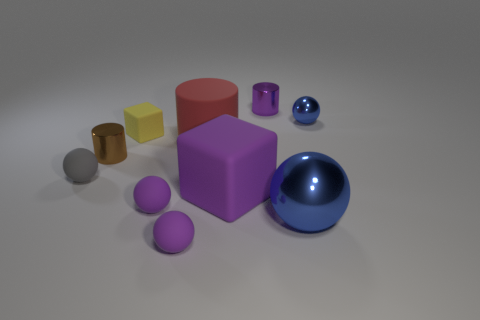There is a small shiny object that is the same shape as the big metallic thing; what color is it? The small shiny object that shares its spherical shape with the larger metallic sphere is blue, exhibiting a rich and vibrant hue that strikingly stands out against the neutral background. 